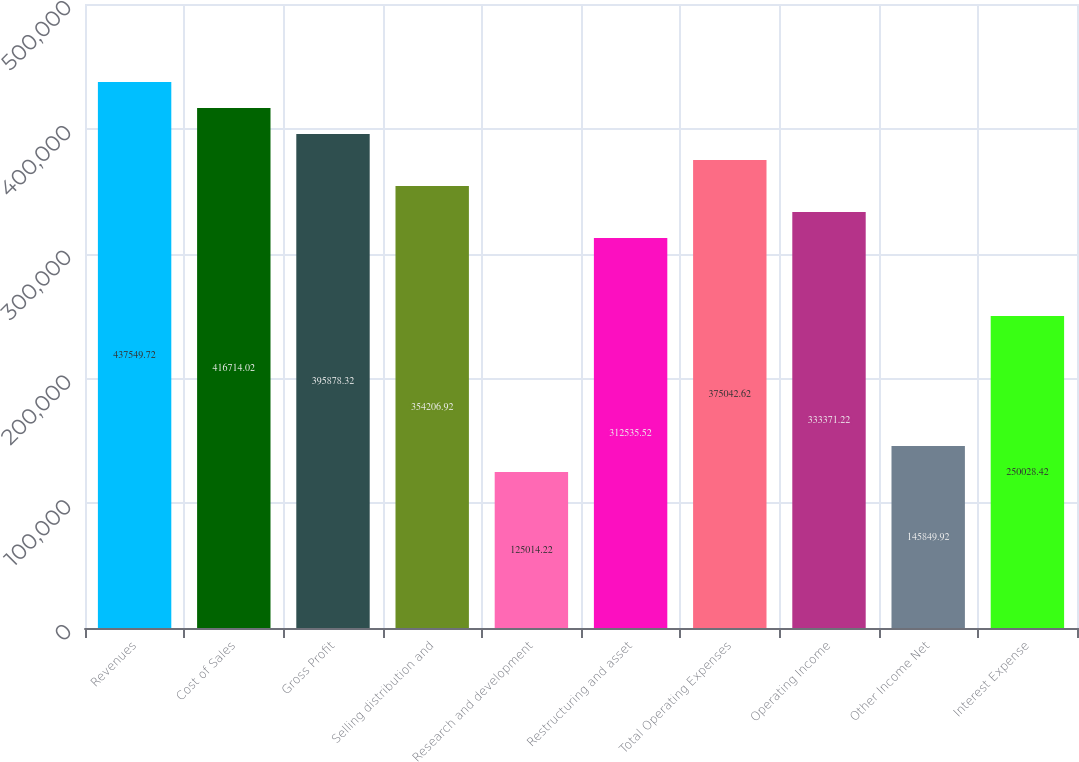Convert chart. <chart><loc_0><loc_0><loc_500><loc_500><bar_chart><fcel>Revenues<fcel>Cost of Sales<fcel>Gross Profit<fcel>Selling distribution and<fcel>Research and development<fcel>Restructuring and asset<fcel>Total Operating Expenses<fcel>Operating Income<fcel>Other Income Net<fcel>Interest Expense<nl><fcel>437550<fcel>416714<fcel>395878<fcel>354207<fcel>125014<fcel>312536<fcel>375043<fcel>333371<fcel>145850<fcel>250028<nl></chart> 